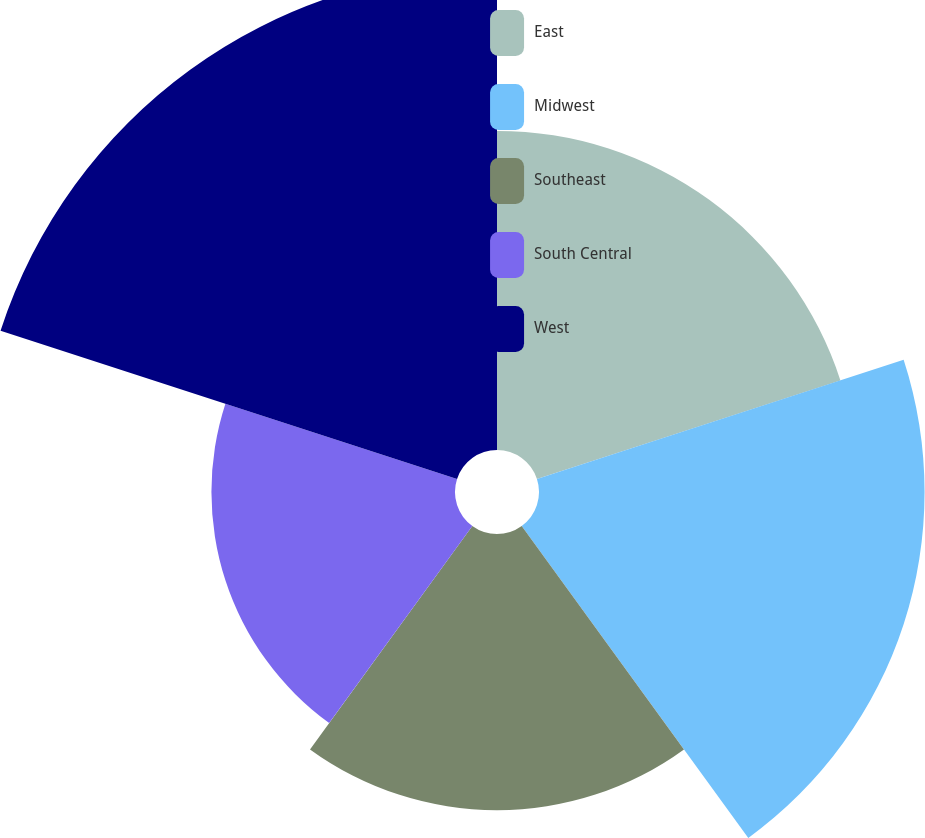Convert chart to OTSL. <chart><loc_0><loc_0><loc_500><loc_500><pie_chart><fcel>East<fcel>Midwest<fcel>Southeast<fcel>South Central<fcel>West<nl><fcel>18.72%<fcel>22.62%<fcel>16.2%<fcel>14.29%<fcel>28.16%<nl></chart> 